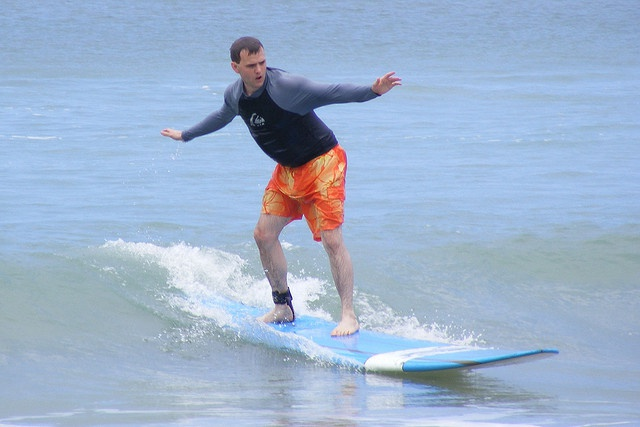Describe the objects in this image and their specific colors. I can see people in darkgray, black, and gray tones and surfboard in darkgray, lightblue, and lavender tones in this image. 